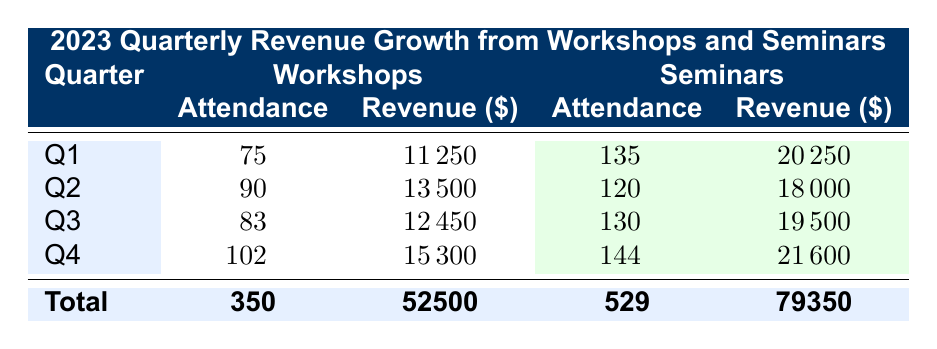What is the total revenue generated from workshops in Q1? The table shows that in Q1, the revenue from workshops is $6750 + $4500 = $11250.
Answer: 11250 What is the total attendance for seminars in Q3? In Q3, the attendance for seminars is 70 + 60 = 130.
Answer: 130 In which quarter did the workshops generate the highest revenue? The revenues for workshops are $11250 in Q1, $13500 in Q2, $12450 in Q3, and $15300 in Q4. The highest revenue is in Q4.
Answer: Q4 What is the average attendance across all quarters for workshops? The total attendance for workshops is 75 + 90 + 83 + 102 = 350 and there are 4 quarters, so the average attendance is 350 / 4 = 87.5.
Answer: 87.5 Did the attendance for seminars increase from Q2 to Q3? In Q2, the attendance for seminars is 65 + 55 = 120, and in Q3 it is 70 + 60 = 130. Since 130 > 120, the attendance increased.
Answer: Yes What is the total revenue generated from both workshops and seminars in Q2? The total revenue for Q2 is $13500 from workshops and $18000 from seminars, so the total is $13500 + $18000 = $31500.
Answer: 31500 What is the difference in total revenue between Q1 and Q4? The total revenue in Q1 is $11250 (workshops) + $20250 (seminars) = $31500, and in Q4 it is $15300 (workshops) + $21600 (seminars) = $36900. The difference is $36900 - $31500 = $5400.
Answer: 5400 Which quarter had the least revenue from workshops? The revenues from workshops are $11250 in Q1, $13500 in Q2, $12450 in Q3, and $15300 in Q4. The least revenue is in Q1.
Answer: Q1 Was the total attendance for seminars higher in Q4 than in Q1? The total attendance for seminars is 135 in Q1 and 144 in Q4, and since 144 > 135, the total attendance was higher in Q4.
Answer: Yes 